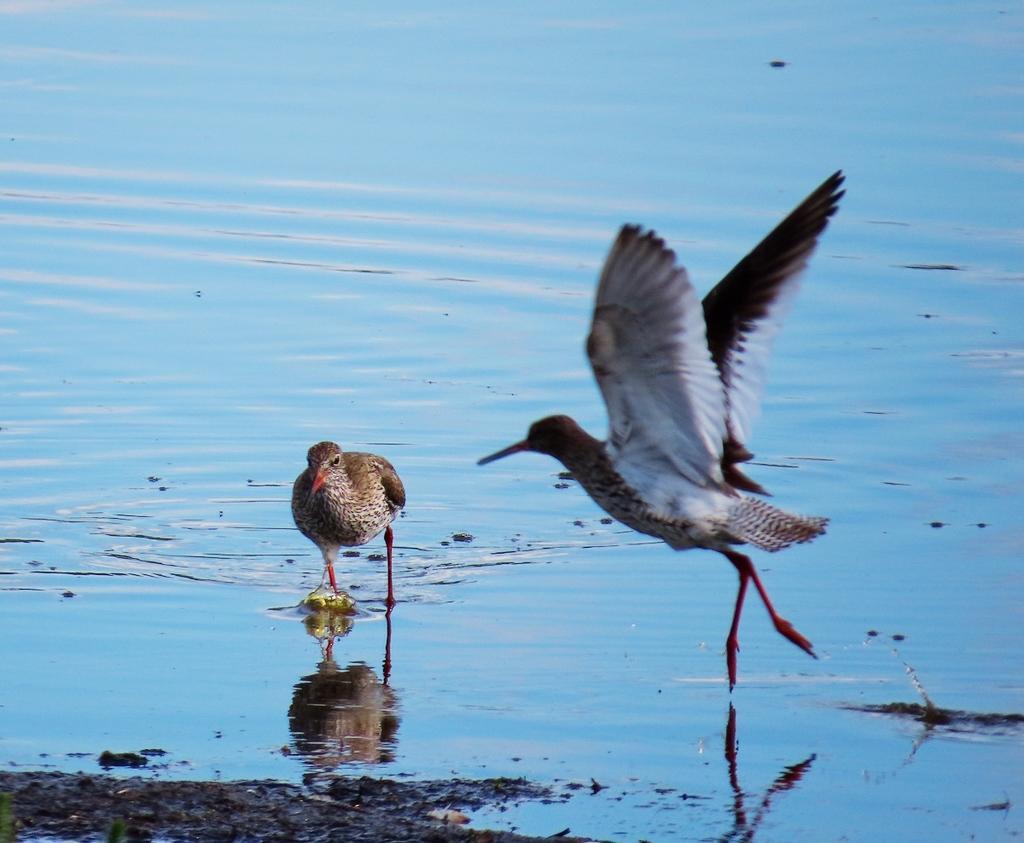In one or two sentences, can you explain what this image depicts? In this image in the center there are two cranes, and at the bottom there is a lake and sand. 